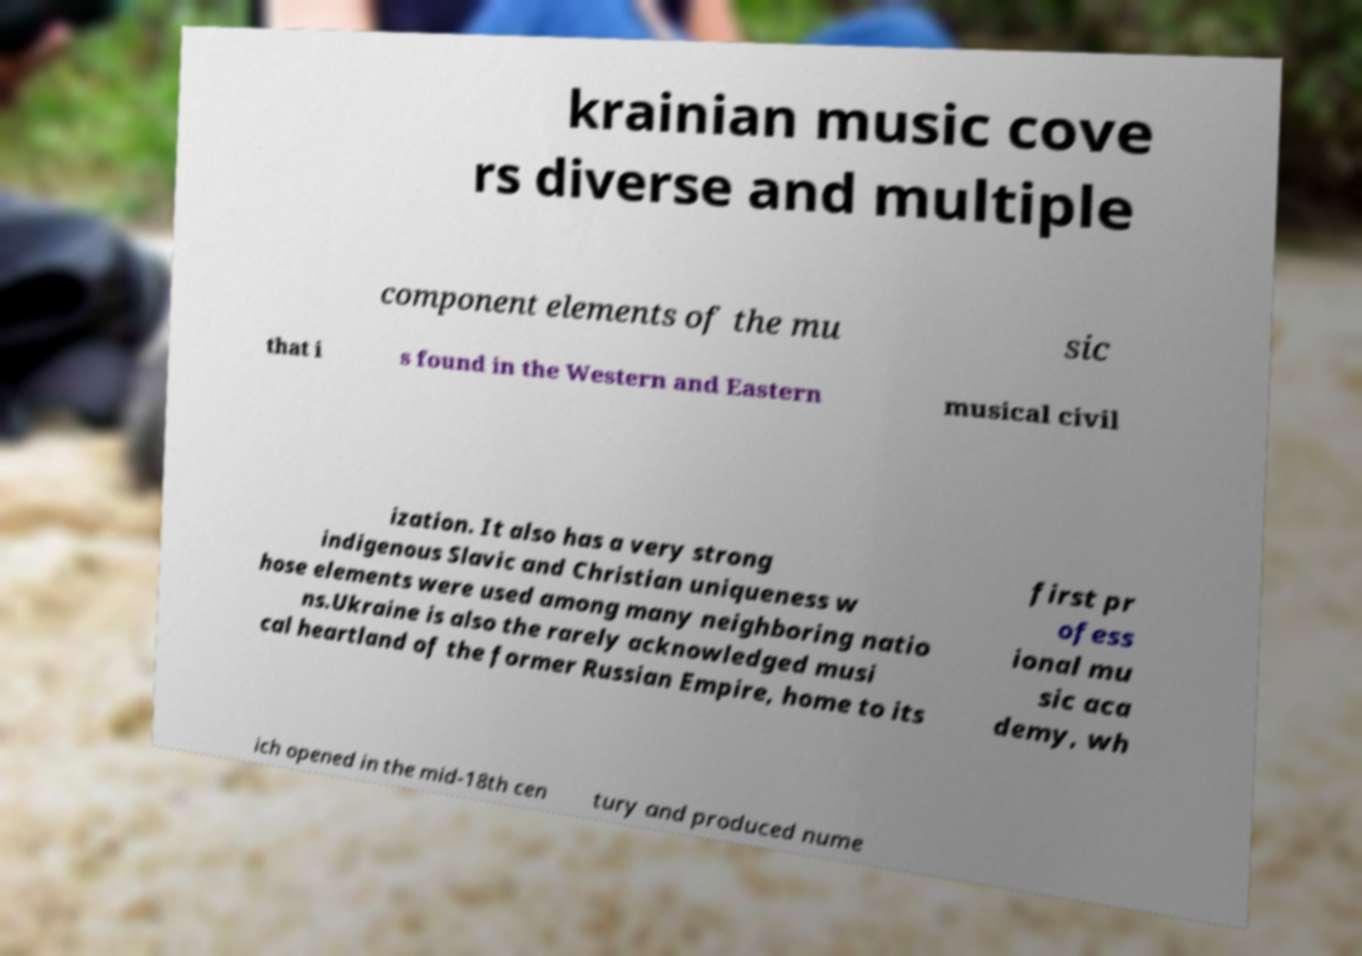Please read and relay the text visible in this image. What does it say? krainian music cove rs diverse and multiple component elements of the mu sic that i s found in the Western and Eastern musical civil ization. It also has a very strong indigenous Slavic and Christian uniqueness w hose elements were used among many neighboring natio ns.Ukraine is also the rarely acknowledged musi cal heartland of the former Russian Empire, home to its first pr ofess ional mu sic aca demy, wh ich opened in the mid-18th cen tury and produced nume 